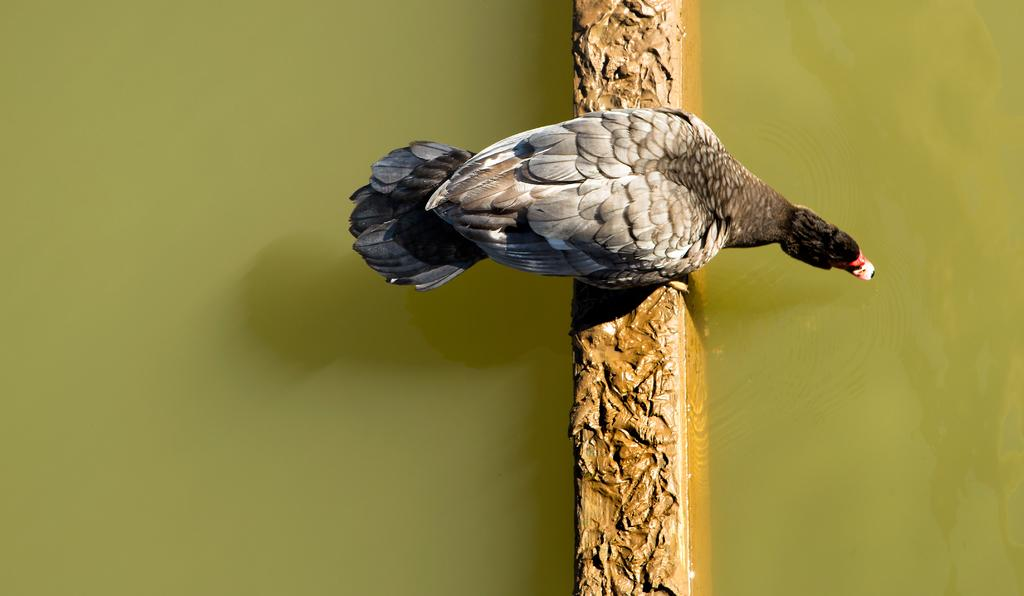What type of animal can be seen on the wall in the image? There is a bird on the wall in the image. What natural element is visible in the image? Water is visible in the image. Where is the station located in the image? There is no station present in the image. What type of insect can be seen on the bird in the image? There are no insects, including ladybugs, present in the image. 